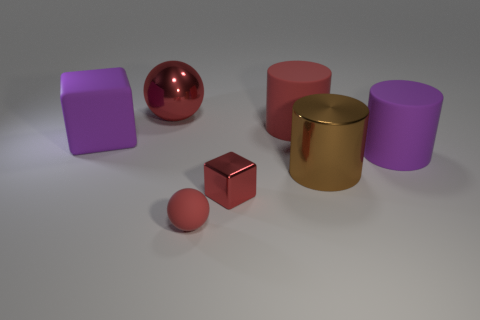Subtract all matte cylinders. How many cylinders are left? 1 Subtract all purple cylinders. How many cylinders are left? 2 Subtract 1 blocks. How many blocks are left? 1 Subtract all blue blocks. How many red cylinders are left? 1 Add 2 tiny matte spheres. How many objects exist? 9 Subtract 0 gray cylinders. How many objects are left? 7 Subtract all cylinders. How many objects are left? 4 Subtract all blue spheres. Subtract all red cylinders. How many spheres are left? 2 Subtract all red cubes. Subtract all brown things. How many objects are left? 5 Add 5 big purple blocks. How many big purple blocks are left? 6 